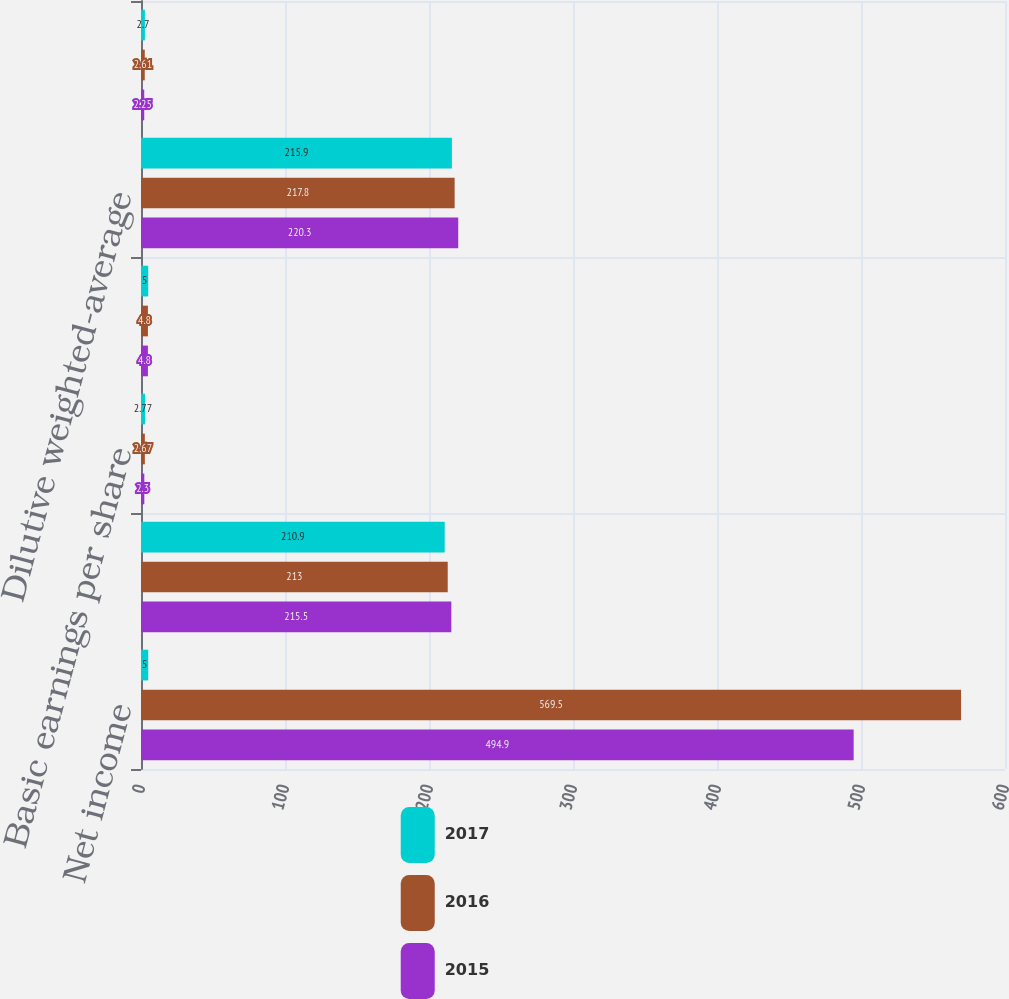Convert chart. <chart><loc_0><loc_0><loc_500><loc_500><stacked_bar_chart><ecel><fcel>Net income<fcel>Weighted-average shares<fcel>Basic earnings per share<fcel>Dilutive effect of stock plans<fcel>Dilutive weighted-average<fcel>Diluted earnings per share<nl><fcel>2017<fcel>5<fcel>210.9<fcel>2.77<fcel>5<fcel>215.9<fcel>2.7<nl><fcel>2016<fcel>569.5<fcel>213<fcel>2.67<fcel>4.8<fcel>217.8<fcel>2.61<nl><fcel>2015<fcel>494.9<fcel>215.5<fcel>2.3<fcel>4.8<fcel>220.3<fcel>2.25<nl></chart> 